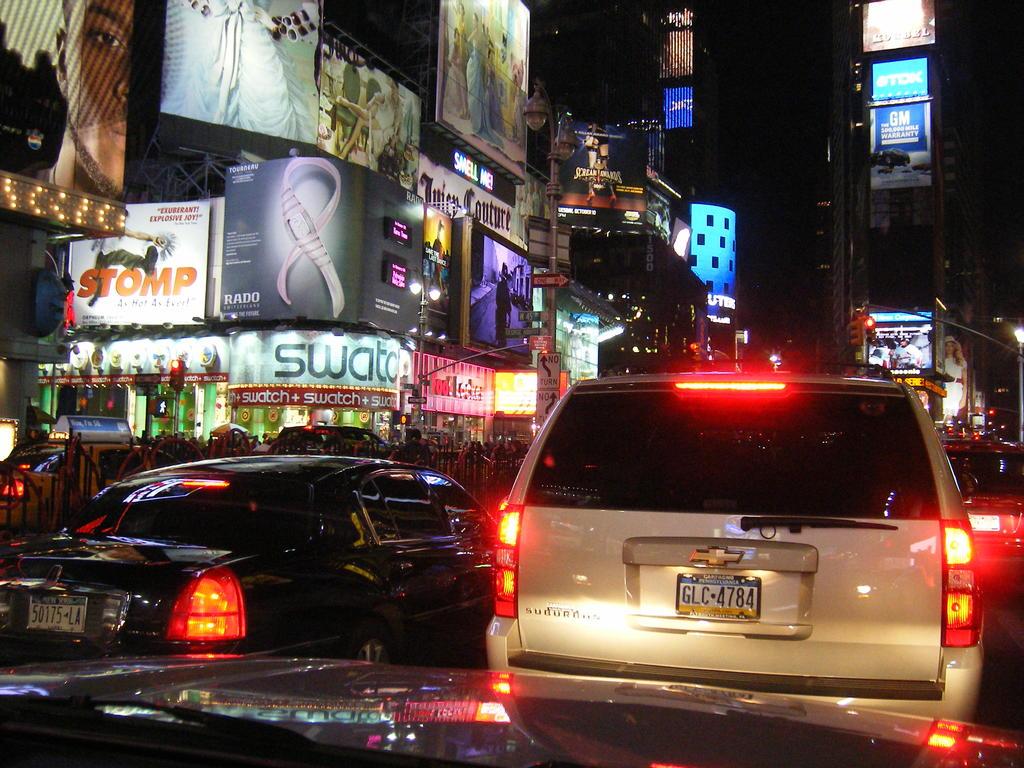What is the name of the play in orange lettering?
Your answer should be compact. Stomp. 